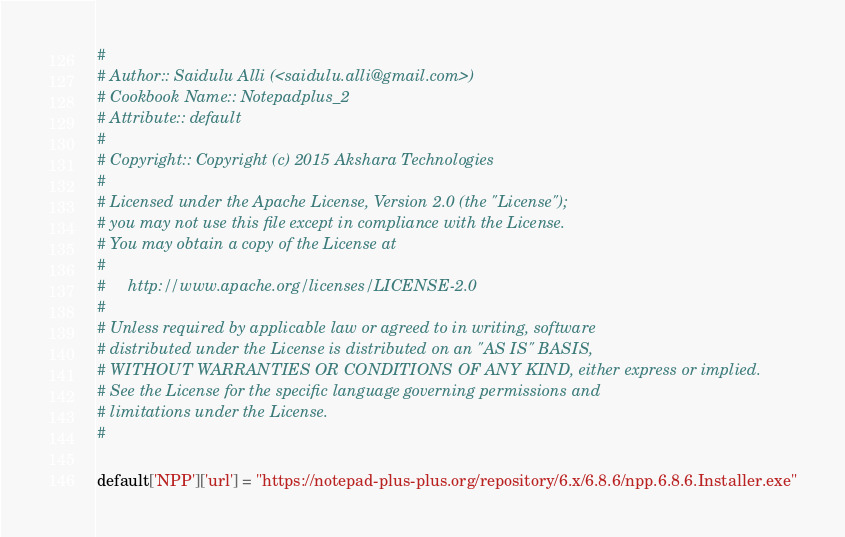Convert code to text. <code><loc_0><loc_0><loc_500><loc_500><_Ruby_>#
# Author:: Saidulu Alli (<saidulu.alli@gmail.com>)
# Cookbook Name:: Notepadplus_2
# Attribute:: default
#
# Copyright:: Copyright (c) 2015 Akshara Technologies
#
# Licensed under the Apache License, Version 2.0 (the "License");
# you may not use this file except in compliance with the License.
# You may obtain a copy of the License at
#
#     http://www.apache.org/licenses/LICENSE-2.0
#
# Unless required by applicable law or agreed to in writing, software
# distributed under the License is distributed on an "AS IS" BASIS,
# WITHOUT WARRANTIES OR CONDITIONS OF ANY KIND, either express or implied.
# See the License for the specific language governing permissions and
# limitations under the License.
#

default['NPP']['url'] = "https://notepad-plus-plus.org/repository/6.x/6.8.6/npp.6.8.6.Installer.exe"
</code> 